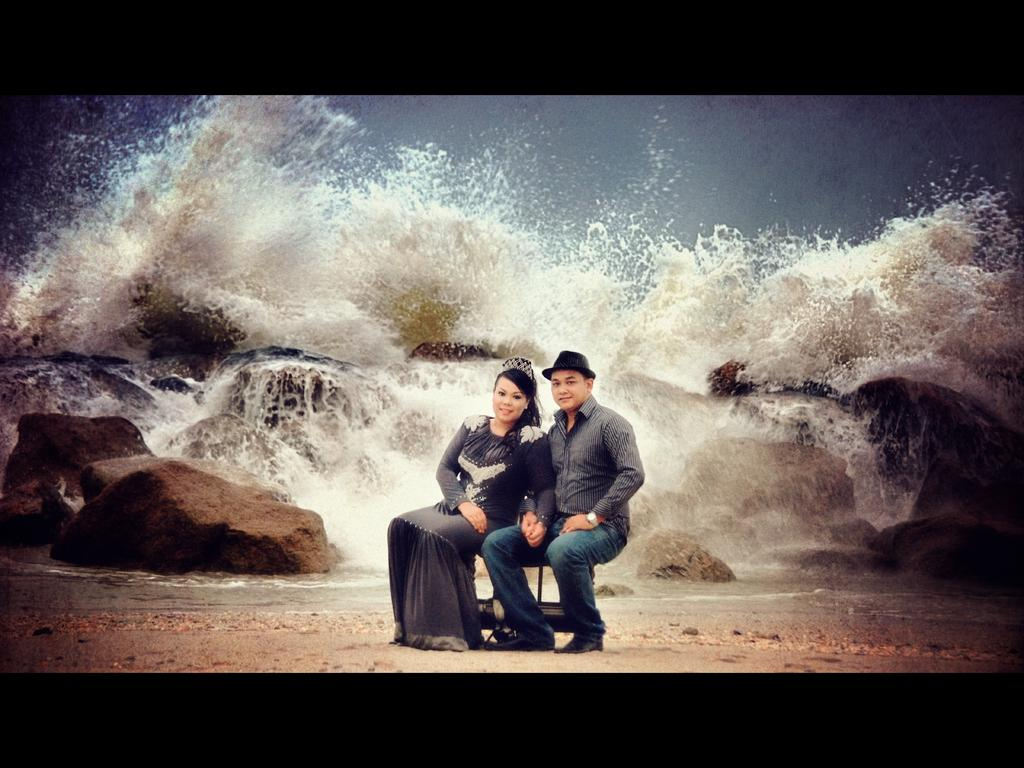Who are the people in the image? There is a man and a woman in the image. What are they doing in the image? They are sitting on a bench. Where is the bench located? The bench is near the sea. What is the ground made of? The ground is sand. What can be seen in the background of the image? There are rocks visible in the background, and water is flowing from the rocks with pressure. What type of clouds can be seen in the image? There are no clouds visible in the image; it features a man and a woman sitting on a bench near the sea, with rocks and flowing water in the background. Is there a plough visible in the image? No, there is no plough present in the image. 